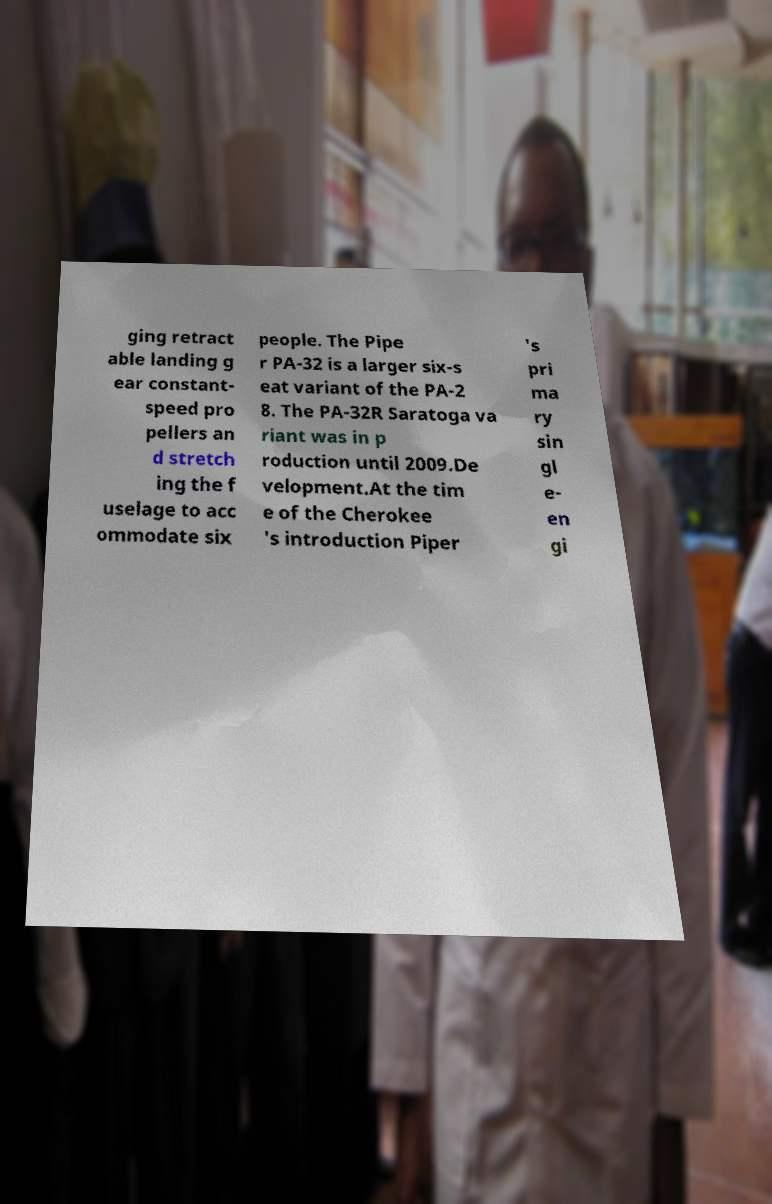Could you extract and type out the text from this image? ging retract able landing g ear constant- speed pro pellers an d stretch ing the f uselage to acc ommodate six people. The Pipe r PA-32 is a larger six-s eat variant of the PA-2 8. The PA-32R Saratoga va riant was in p roduction until 2009.De velopment.At the tim e of the Cherokee 's introduction Piper 's pri ma ry sin gl e- en gi 